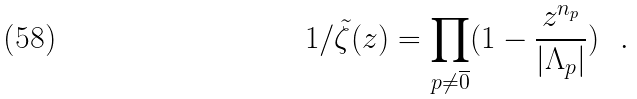Convert formula to latex. <formula><loc_0><loc_0><loc_500><loc_500>1 / \tilde { \zeta } ( z ) = \prod _ { p \neq \overline { 0 } } ( 1 - \frac { z ^ { n _ { p } } } { | \Lambda _ { p } | } ) \ \ .</formula> 